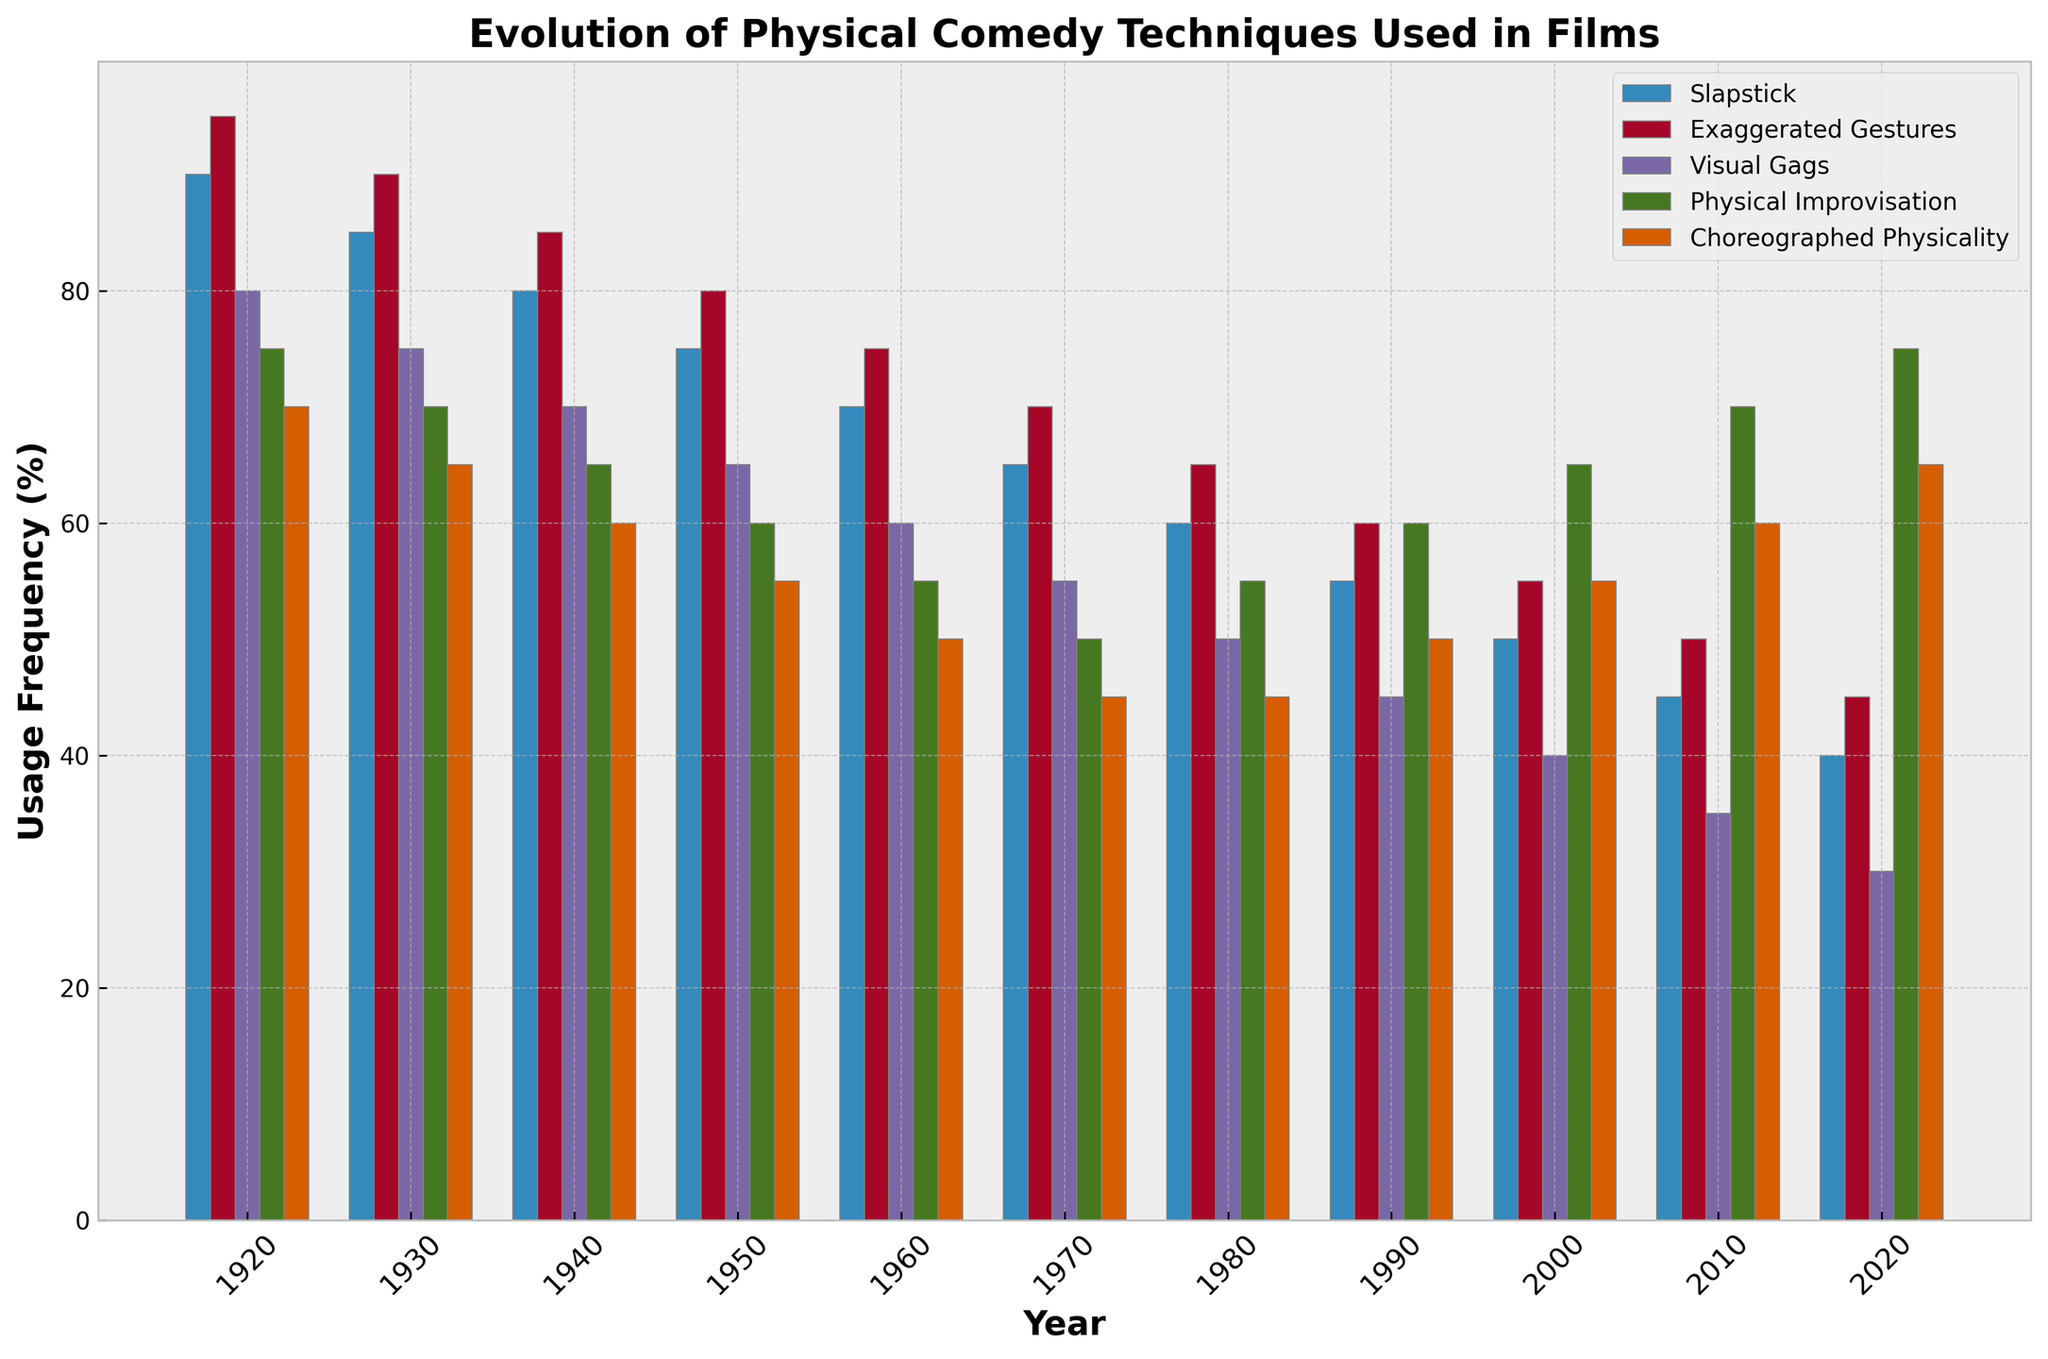What's the overall trend in the usage of 'Slapstick' from 1920 to 2020? The figure shows a bar for 'Slapstick' for each decade. By observing these bars, we can see that 'Slapstick' usage decreases over time. The height of the bars consistently gets shorter from 1920 (90%) to 2020 (40%), indicating a decreasing trend.
Answer: Decreasing Which comedy technique was most frequently used in 1950? By comparing the heights of the bars for each technique in the year 1950, we see that 'Slapstick' has the highest bar at 75%.
Answer: Slapstick In which year did the technique 'Exaggerated Gestures' have the same frequency as 'Visual Gags'? Looking at the data table, 'Exaggerated Gestures' and 'Visual Gags' have the same value of 50% in 1980. This can also be observed in the figure by noting the bar heights are equal for these two techniques in 1980.
Answer: 1980 How did the usage frequency of 'Physical Improvisation' change from 1920 to 2020? From the figure, the heights of the bars for 'Physical Improvisation' increase gradually over the decades. They go from 75% in 1920 to 75% again in 2020, but in between, the usage drops to 50% by 1970 and then increases to 75% by 2020.
Answer: Increase Which technique experienced the smallest change in usage frequency from 1920 to 2020? By observing the initial and final bars for each technique, 'Slapstick' decreases by 50 percentage points (90% to 40%), 'Exaggerated Gestures' by 50 percentage points (95% to 45%), 'Visual Gags' by 50 percentage points (80% to 30%), 'Physical Improvisation' by 0 percentage points (75% to 75%), and 'Choreographed Physicality' by 5 percentage points (70% to 65%). 'Choreographed Physicality' has the smallest change.
Answer: Choreographed Physicality In which decade was 'Slapstick' used more frequently compared to 'Exaggerated Gestures'? By analyzing the decade bars for both techniques, 'Slapstick' has higher bars in the 1920s (90% vs. 95%) and the 1930s (85% vs. 90%).
Answer: None For which decades did 'Choreographed Physicality' show a steady increase in usage? By looking at the heights of the 'Choreographed Physicality' bars, we can see steady increases from 1990 (50%) to 2000 (55%), to 2010 (60%), and then to 2020 (65%).
Answer: 1990-2020 What's the average frequency of 'Visual Gags' usage over the entire period? To find the average, sum the values of 'Visual Gags' over different years and divide by the number of years. (80+75+70+65+60+55+50+45+40+35+30)/11 = 55.
Answer: 55 Compare the usage of 'Physical Improvisation' and 'Choreographed Physicality' in the year 2000. In the year 2000, 'Physical Improvisation' has a value of 65% while 'Choreographed Physicality' has a value of 55%. Observing the bar heights, 'Physical Improvisation' has a taller bar than 'Choreographed Physicality'.
Answer: Physical Improvisation higher 